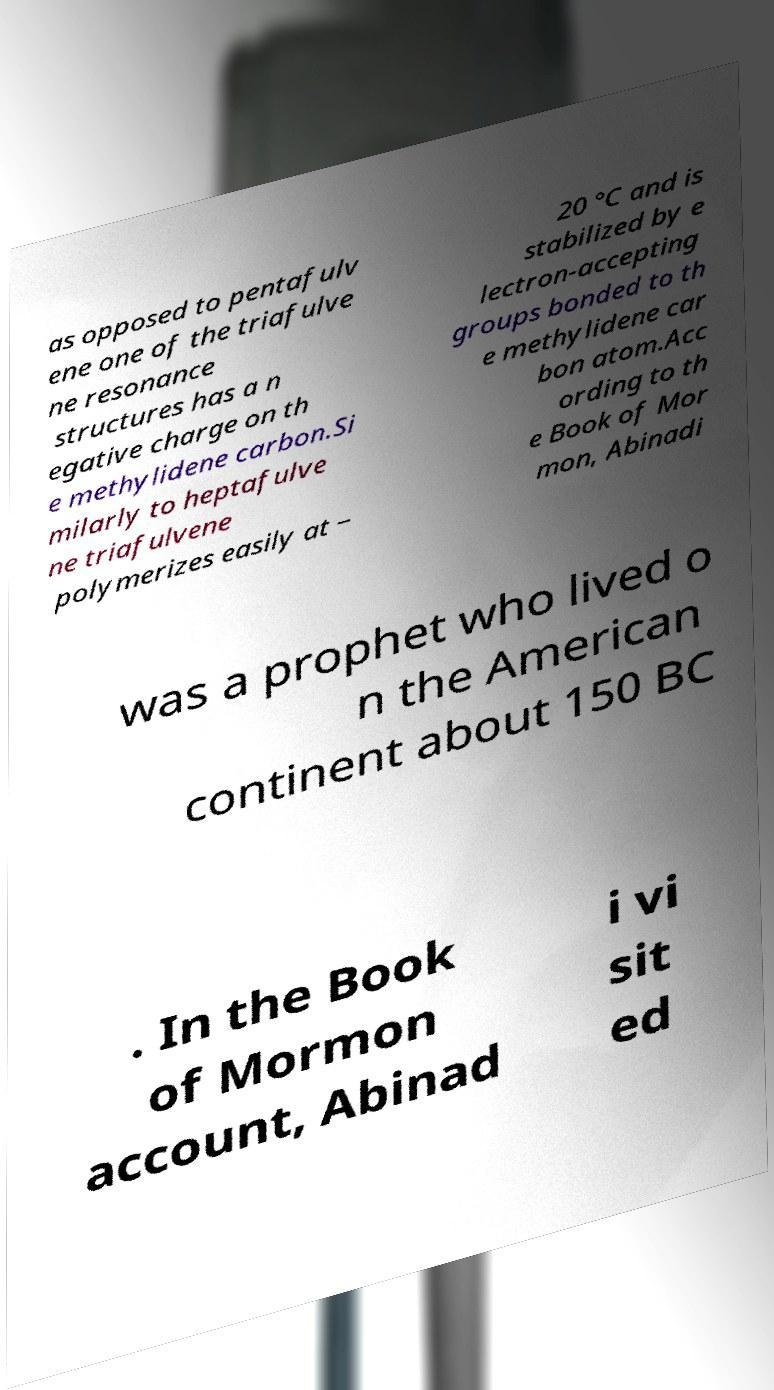I need the written content from this picture converted into text. Can you do that? as opposed to pentafulv ene one of the triafulve ne resonance structures has a n egative charge on th e methylidene carbon.Si milarly to heptafulve ne triafulvene polymerizes easily at − 20 °C and is stabilized by e lectron-accepting groups bonded to th e methylidene car bon atom.Acc ording to th e Book of Mor mon, Abinadi was a prophet who lived o n the American continent about 150 BC . In the Book of Mormon account, Abinad i vi sit ed 